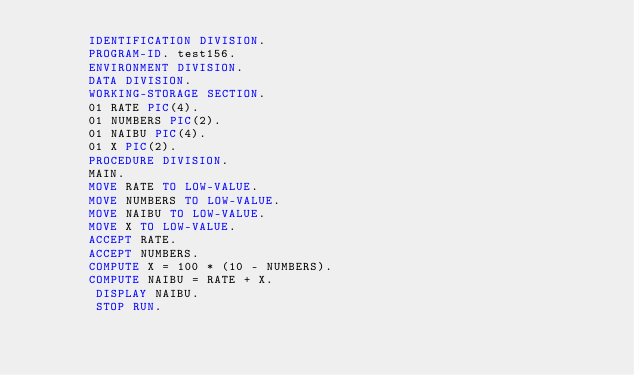Convert code to text. <code><loc_0><loc_0><loc_500><loc_500><_COBOL_>       IDENTIFICATION DIVISION.
       PROGRAM-ID. test156.
       ENVIRONMENT DIVISION.
       DATA DIVISION.
       WORKING-STORAGE SECTION.
       01 RATE PIC(4).
       01 NUMBERS PIC(2).
       01 NAIBU PIC(4).
       01 X PIC(2).
       PROCEDURE DIVISION.
       MAIN.
       MOVE RATE TO LOW-VALUE.
       MOVE NUMBERS TO LOW-VALUE. 
       MOVE NAIBU TO LOW-VALUE. 
       MOVE X TO LOW-VALUE.       
       ACCEPT RATE.
       ACCEPT NUMBERS.
       COMPUTE X = 100 * (10 - NUMBERS).
       COMPUTE NAIBU = RATE + X.
      	DISPLAY NAIBU.
        STOP RUN.</code> 